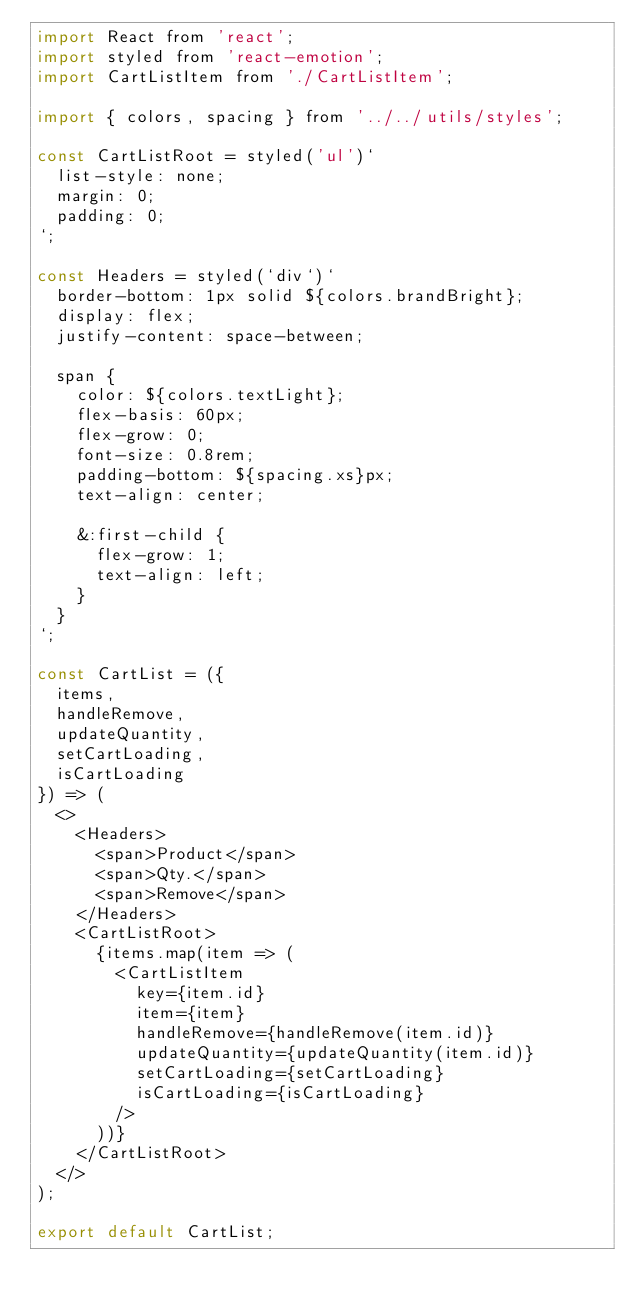Convert code to text. <code><loc_0><loc_0><loc_500><loc_500><_JavaScript_>import React from 'react';
import styled from 'react-emotion';
import CartListItem from './CartListItem';

import { colors, spacing } from '../../utils/styles';

const CartListRoot = styled('ul')`
  list-style: none;
  margin: 0;
  padding: 0;
`;

const Headers = styled(`div`)`
  border-bottom: 1px solid ${colors.brandBright};
  display: flex;
  justify-content: space-between;

  span {
    color: ${colors.textLight};
    flex-basis: 60px;
    flex-grow: 0;
    font-size: 0.8rem;
    padding-bottom: ${spacing.xs}px;
    text-align: center;

    &:first-child {
      flex-grow: 1;
      text-align: left;
    }
  }
`;

const CartList = ({
  items,
  handleRemove,
  updateQuantity,
  setCartLoading,
  isCartLoading
}) => (
  <>
    <Headers>
      <span>Product</span>
      <span>Qty.</span>
      <span>Remove</span>
    </Headers>
    <CartListRoot>
      {items.map(item => (
        <CartListItem
          key={item.id}
          item={item}
          handleRemove={handleRemove(item.id)}
          updateQuantity={updateQuantity(item.id)}
          setCartLoading={setCartLoading}
          isCartLoading={isCartLoading}
        />
      ))}
    </CartListRoot>
  </>
);

export default CartList;
</code> 